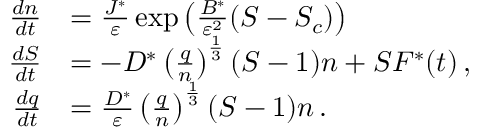Convert formula to latex. <formula><loc_0><loc_0><loc_500><loc_500>\begin{array} { r l } { { \frac { d n } { d t } } } & { = \frac { J ^ { * } } { \varepsilon } \exp \left ( \frac { B ^ { * } } { { \varepsilon } ^ { 2 } } ( S - S _ { c } ) \right ) } \\ { { \frac { d S } { d t } } } & { = { - D ^ { * } \left ( \frac { q } { n } \right ) ^ { \frac { 1 } { 3 } } ( S - 1 ) n + S F ^ { * } ( t ) } \, , } \\ { { \frac { d q } { d t } } } & { = \frac { D ^ { * } } { \varepsilon } \left ( \frac { q } { n } \right ) ^ { \frac { 1 } { 3 } } ( S - 1 ) n \, . } \end{array}</formula> 